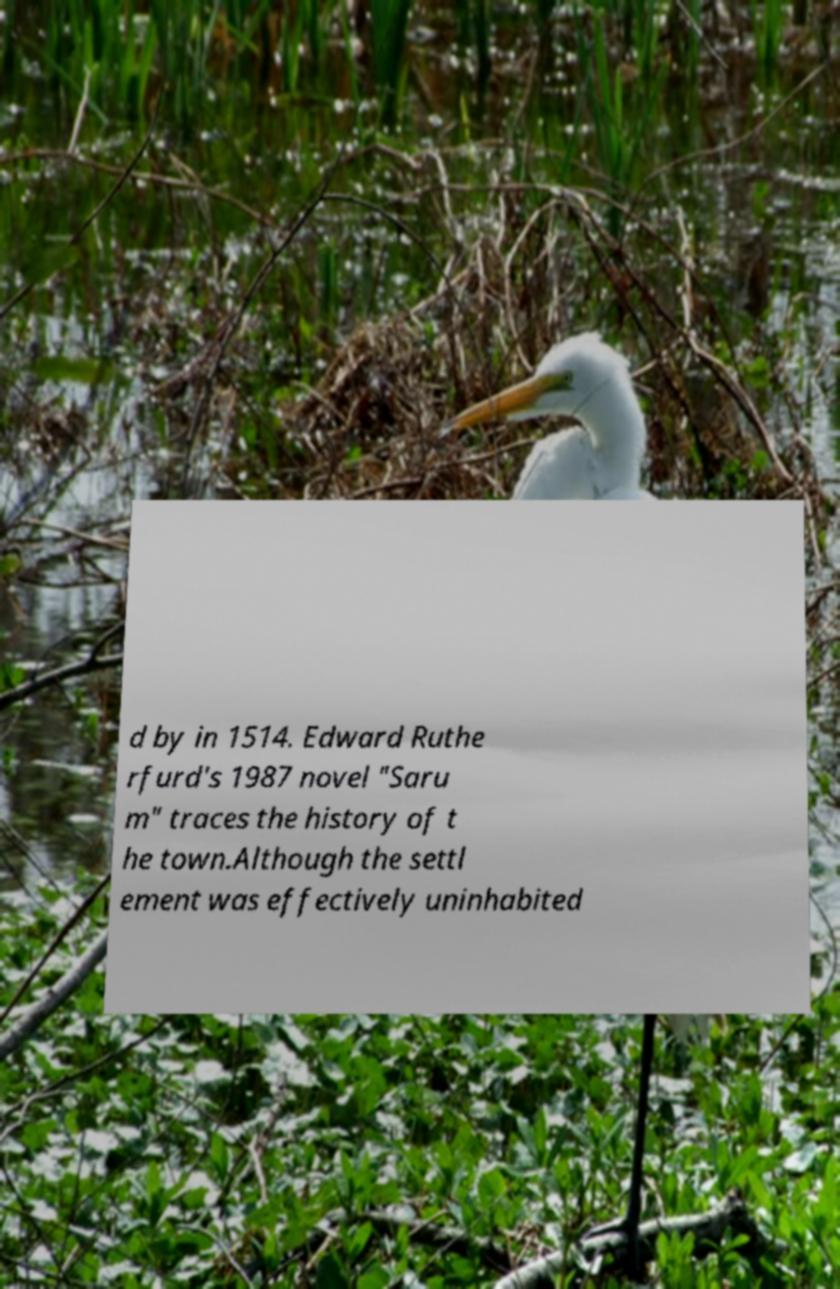Could you extract and type out the text from this image? d by in 1514. Edward Ruthe rfurd's 1987 novel "Saru m" traces the history of t he town.Although the settl ement was effectively uninhabited 